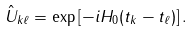<formula> <loc_0><loc_0><loc_500><loc_500>\hat { U } _ { k \ell } = \exp \left [ - i H _ { 0 } ( t _ { k } - t _ { \ell } ) \right ] .</formula> 